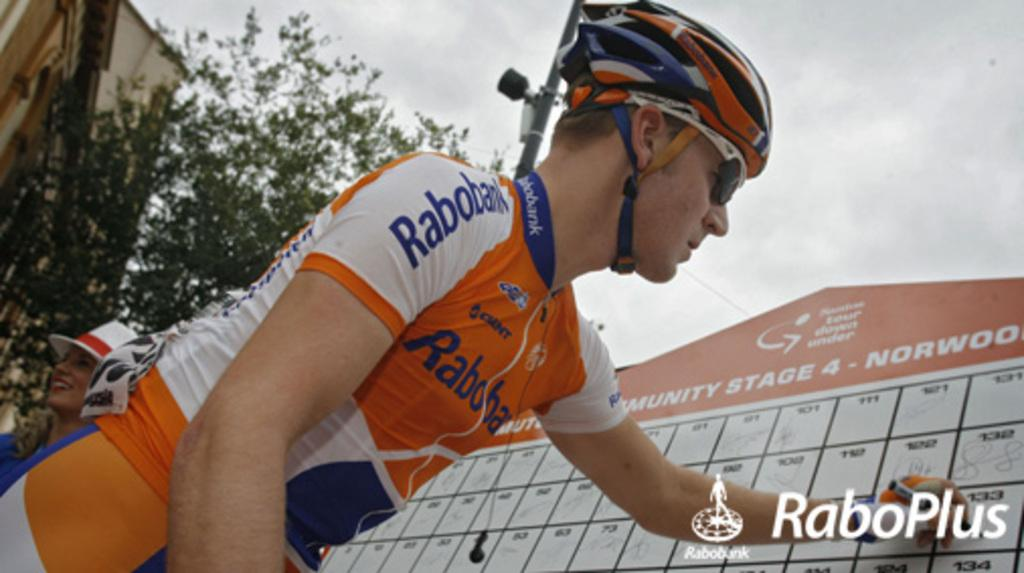How many people are in the image? There are persons standing in the image. What is located behind the persons? There is a banner behind the persons. What can be seen in the background of the image? There are clouds, poles, trees, buildings, and the sky visible in the background. What type of organization is being advertised on the copy in the image? There is no copy present in the image, so it is not possible to determine what type of organization might be advertised. 